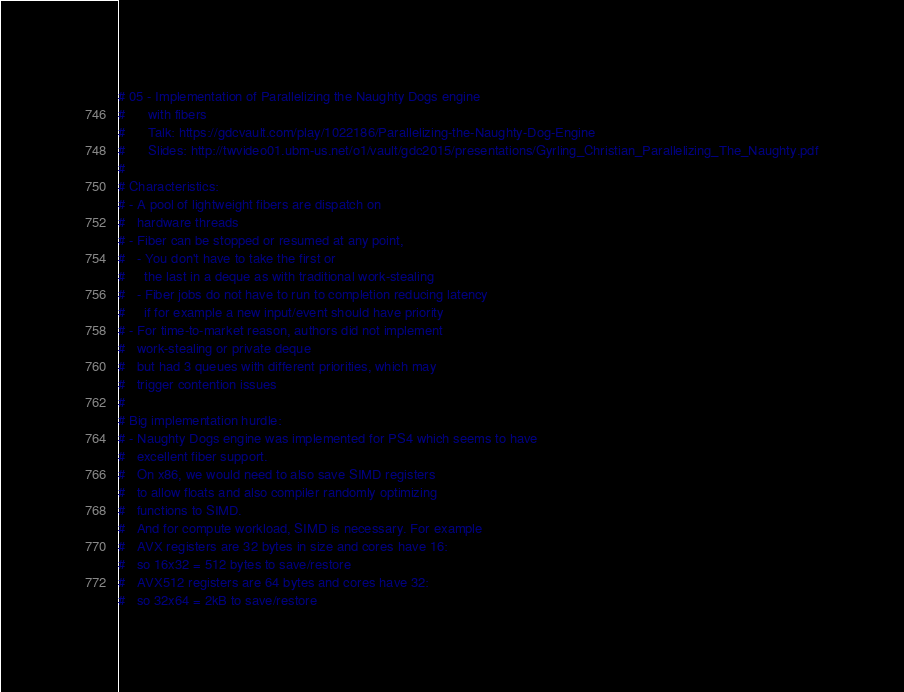<code> <loc_0><loc_0><loc_500><loc_500><_Nim_># 05 - Implementation of Parallelizing the Naughty Dogs engine
#      with fibers
#      Talk: https://gdcvault.com/play/1022186/Parallelizing-the-Naughty-Dog-Engine
#      Slides: http://twvideo01.ubm-us.net/o1/vault/gdc2015/presentations/Gyrling_Christian_Parallelizing_The_Naughty.pdf
#
# Characteristics:
# - A pool of lightweight fibers are dispatch on
#   hardware threads
# - Fiber can be stopped or resumed at any point,
#   - You don't have to take the first or
#     the last in a deque as with traditional work-stealing
#   - Fiber jobs do not have to run to completion reducing latency
#     if for example a new input/event should have priority
# - For time-to-market reason, authors did not implement
#   work-stealing or private deque
#   but had 3 queues with different priorities, which may
#   trigger contention issues
#
# Big implementation hurdle:
# - Naughty Dogs engine was implemented for PS4 which seems to have
#   excellent fiber support.
#   On x86, we would need to also save SIMD registers
#   to allow floats and also compiler randomly optimizing
#   functions to SIMD.
#   And for compute workload, SIMD is necessary. For example
#   AVX registers are 32 bytes in size and cores have 16:
#   so 16x32 = 512 bytes to save/restore
#   AVX512 registers are 64 bytes and cores have 32:
#   so 32x64 = 2kB to save/restore
</code> 